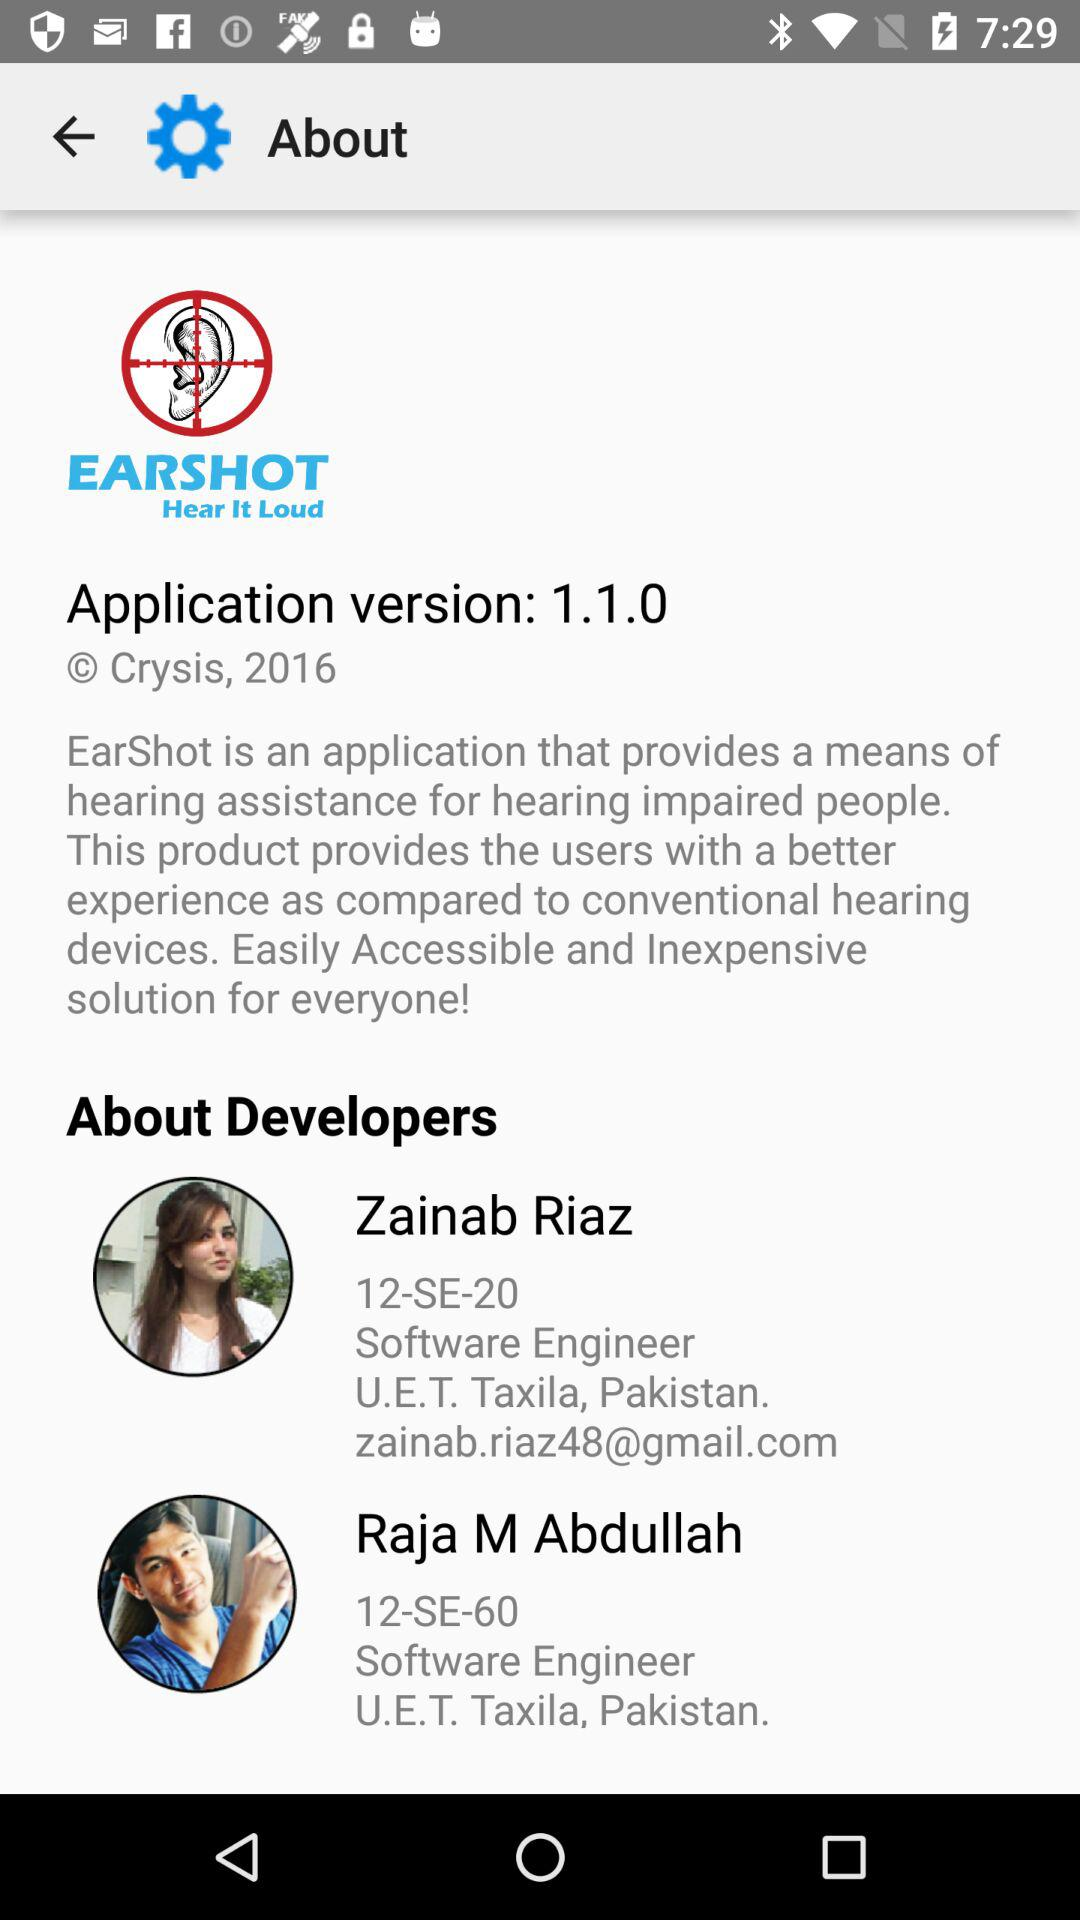What is the app name? The app name is "EarShot". 